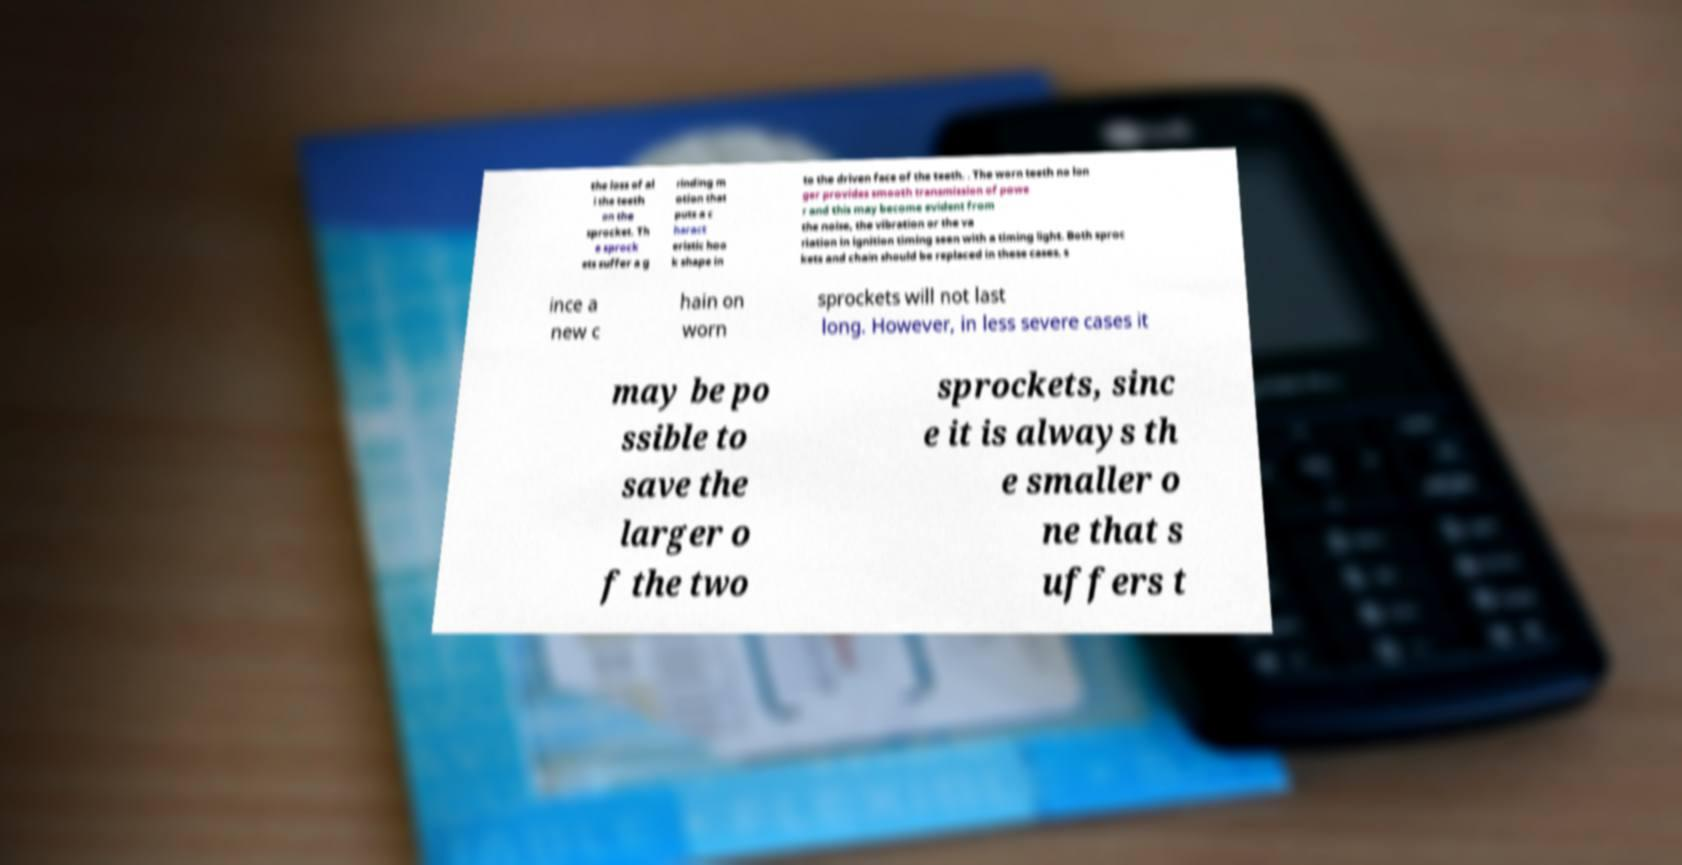Could you extract and type out the text from this image? the loss of al l the teeth on the sprocket. Th e sprock ets suffer a g rinding m otion that puts a c haract eristic hoo k shape in to the driven face of the teeth. . The worn teeth no lon ger provides smooth transmission of powe r and this may become evident from the noise, the vibration or the va riation in ignition timing seen with a timing light. Both sproc kets and chain should be replaced in these cases, s ince a new c hain on worn sprockets will not last long. However, in less severe cases it may be po ssible to save the larger o f the two sprockets, sinc e it is always th e smaller o ne that s uffers t 